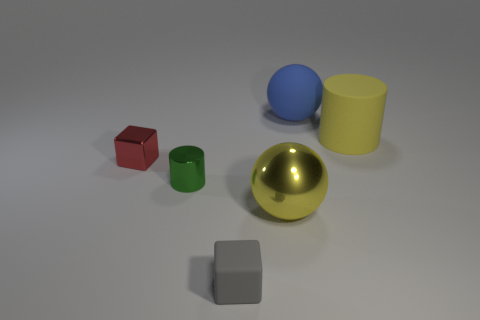Add 4 small brown rubber spheres. How many objects exist? 10 Subtract all cylinders. How many objects are left? 4 Subtract 0 gray spheres. How many objects are left? 6 Subtract all gray rubber cubes. Subtract all cyan balls. How many objects are left? 5 Add 3 large yellow objects. How many large yellow objects are left? 5 Add 2 large cylinders. How many large cylinders exist? 3 